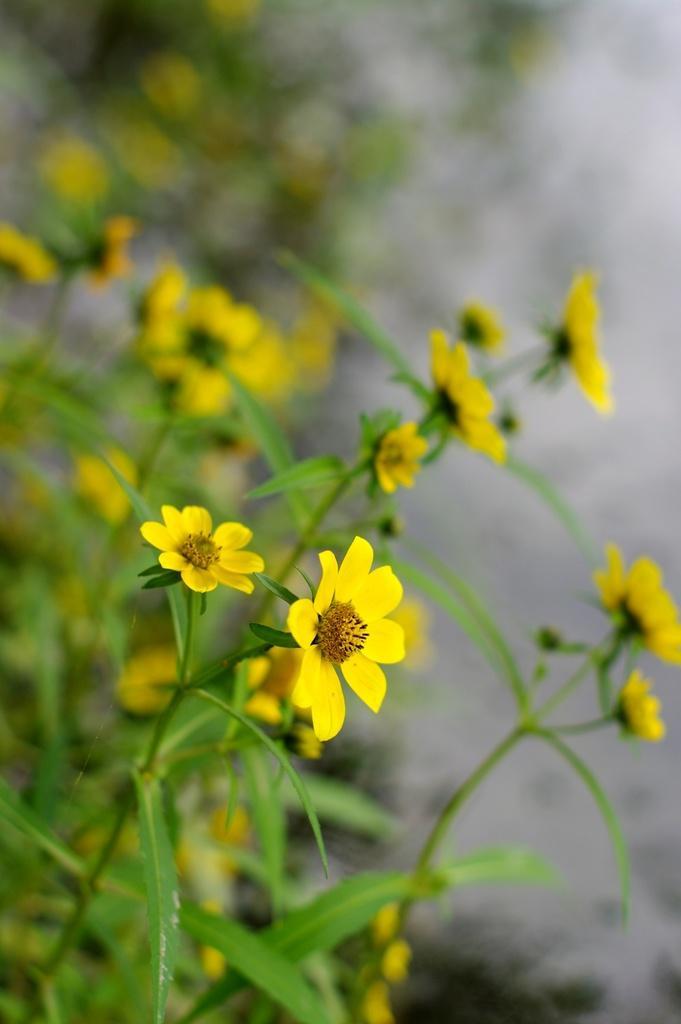Please provide a concise description of this image. In this picture we can see some leaves and flowers in the front, there is a blurry background. 